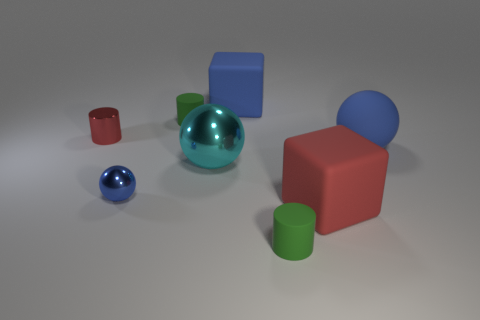There is a sphere that is made of the same material as the red block; what size is it?
Offer a very short reply. Large. What is the red block made of?
Make the answer very short. Rubber. Is there a matte ball that has the same size as the red block?
Your response must be concise. Yes. What material is the ball that is the same size as the cyan thing?
Offer a very short reply. Rubber. What number of large cyan balls are there?
Your answer should be compact. 1. There is a object that is to the right of the large red object; what size is it?
Your response must be concise. Large. Is the number of large matte things to the left of the blue matte ball the same as the number of small green rubber objects?
Your answer should be very brief. Yes. Are there any small green objects that have the same shape as the cyan shiny object?
Make the answer very short. No. What is the shape of the thing that is both in front of the big cyan thing and behind the big red matte thing?
Give a very brief answer. Sphere. Does the big cyan sphere have the same material as the red cylinder behind the tiny metallic ball?
Make the answer very short. Yes. 